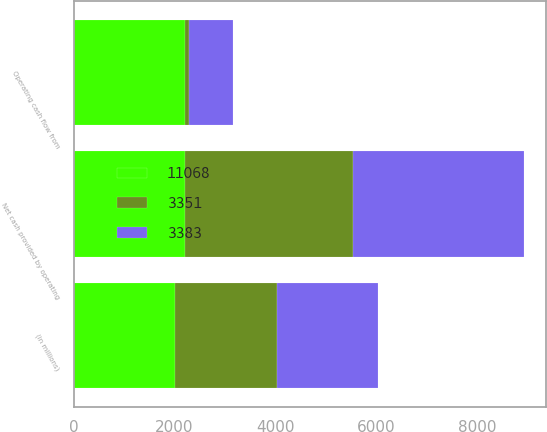Convert chart to OTSL. <chart><loc_0><loc_0><loc_500><loc_500><stacked_bar_chart><ecel><fcel>(in millions)<fcel>Operating cash flow from<fcel>Net cash provided by operating<nl><fcel>3383<fcel>2016<fcel>864<fcel>3383<nl><fcel>3351<fcel>2015<fcel>97<fcel>3351<nl><fcel>11068<fcel>2014<fcel>2197<fcel>2197<nl></chart> 